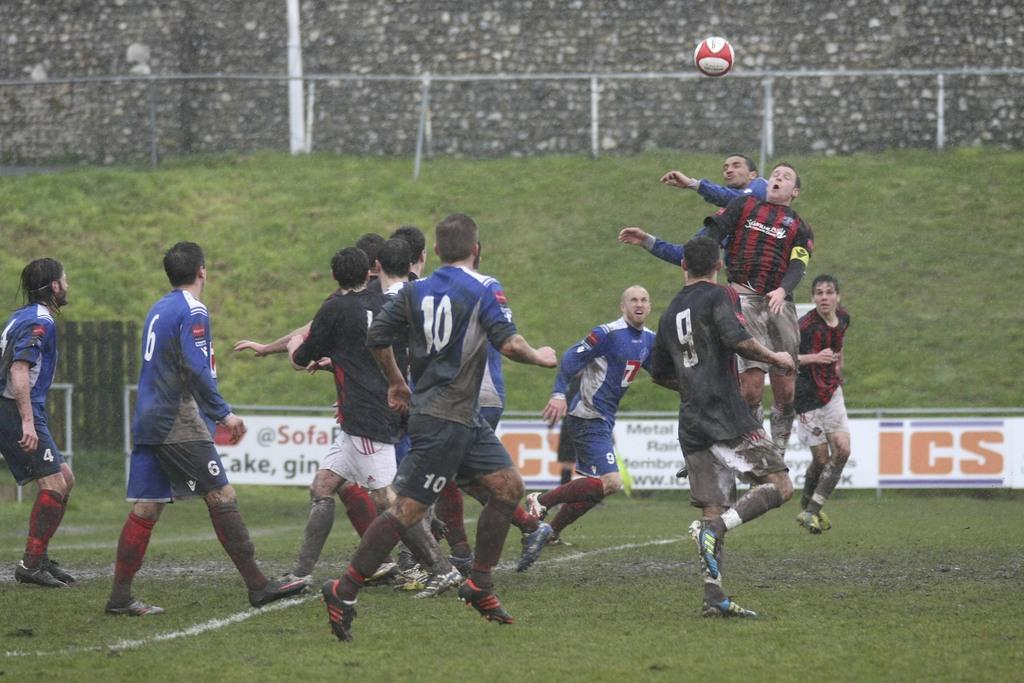<image>
Relay a brief, clear account of the picture shown. A player in a number 10 jersey watches the soccer ball that is up in the air. 